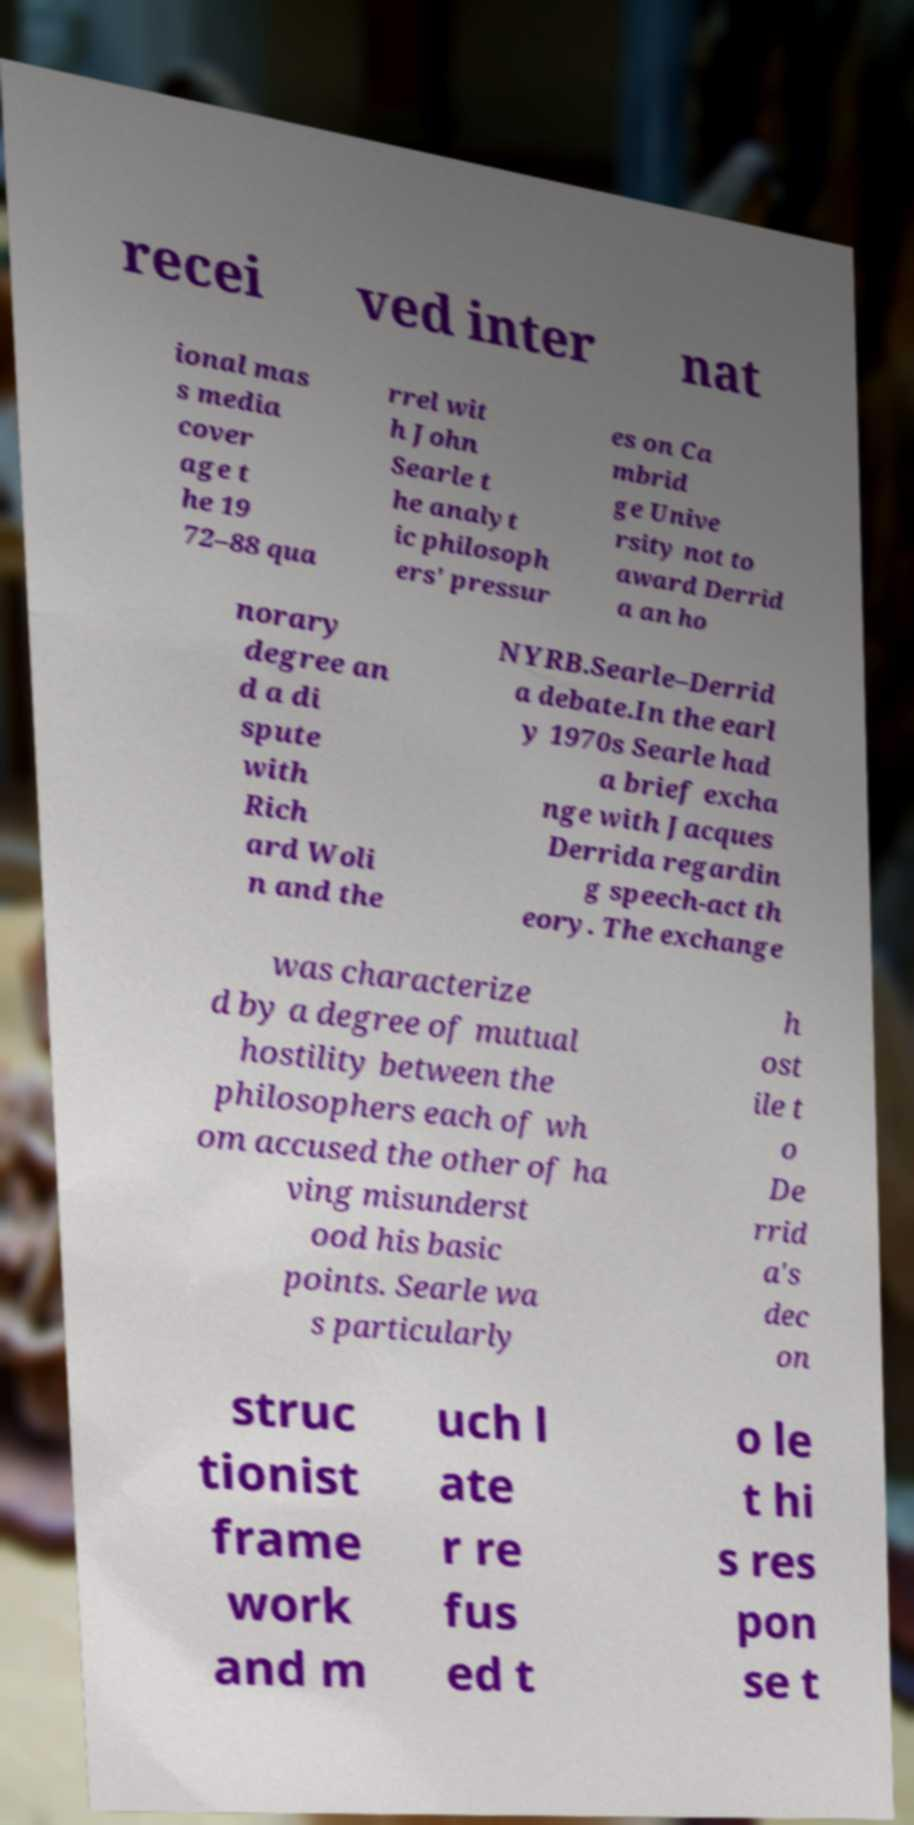Please read and relay the text visible in this image. What does it say? recei ved inter nat ional mas s media cover age t he 19 72–88 qua rrel wit h John Searle t he analyt ic philosoph ers' pressur es on Ca mbrid ge Unive rsity not to award Derrid a an ho norary degree an d a di spute with Rich ard Woli n and the NYRB.Searle–Derrid a debate.In the earl y 1970s Searle had a brief excha nge with Jacques Derrida regardin g speech-act th eory. The exchange was characterize d by a degree of mutual hostility between the philosophers each of wh om accused the other of ha ving misunderst ood his basic points. Searle wa s particularly h ost ile t o De rrid a's dec on struc tionist frame work and m uch l ate r re fus ed t o le t hi s res pon se t 